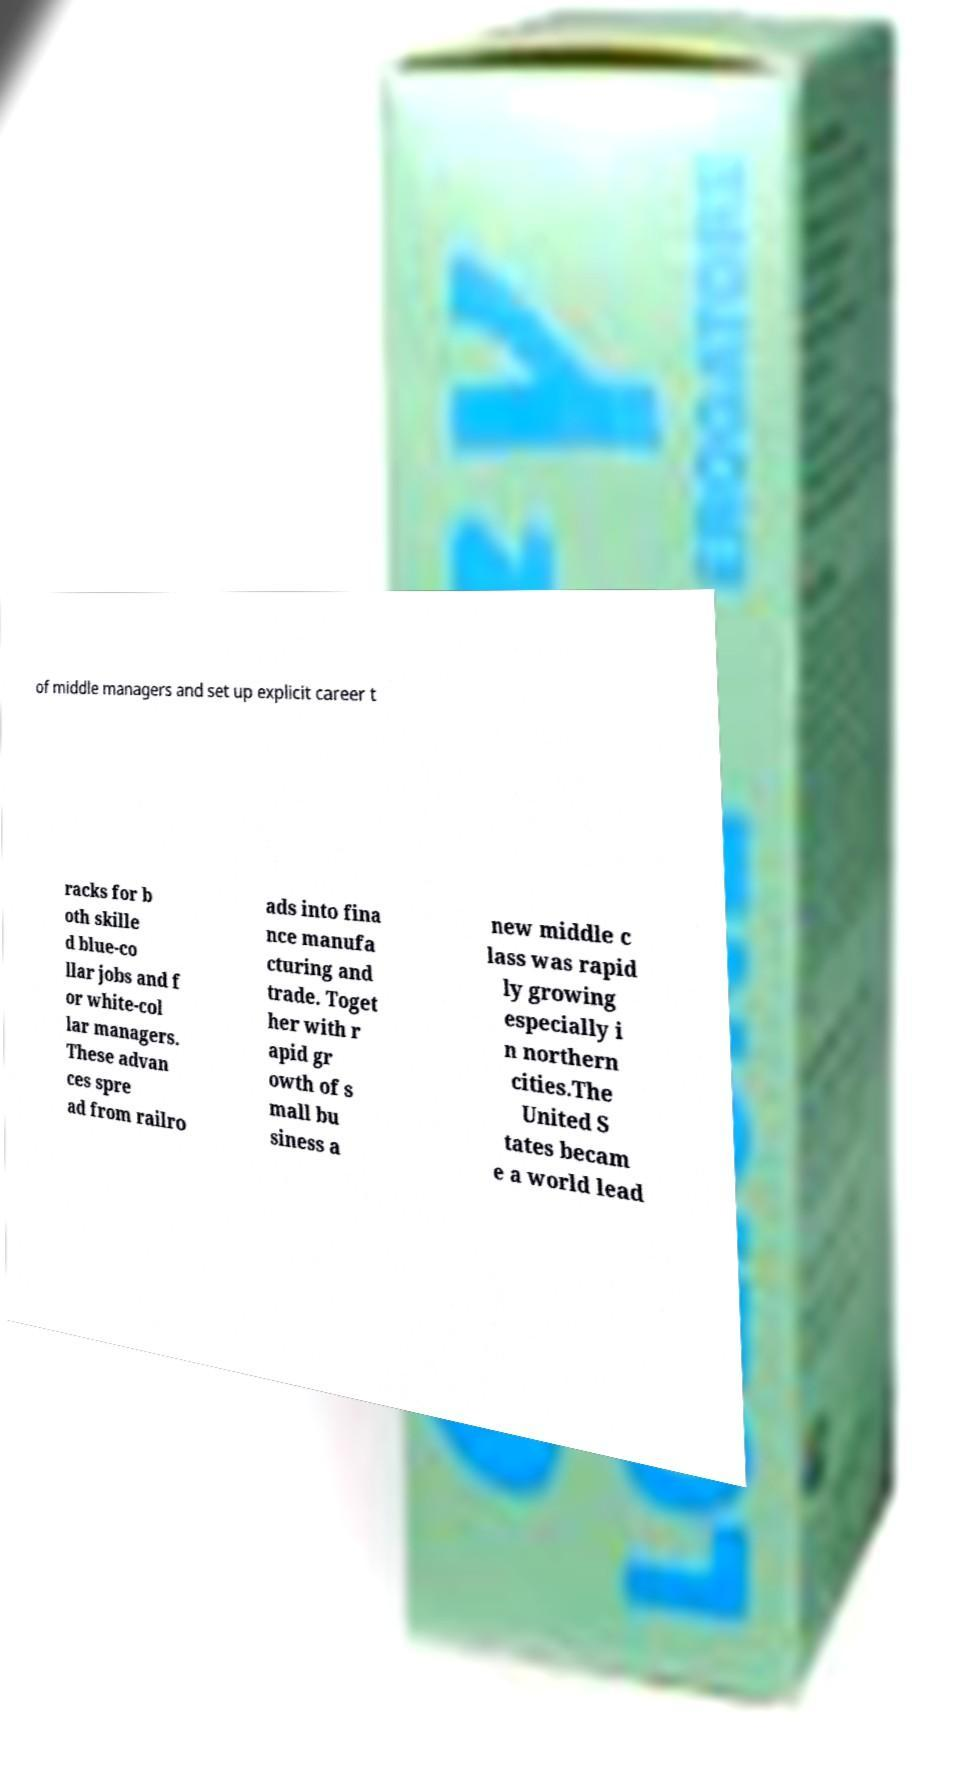Could you extract and type out the text from this image? of middle managers and set up explicit career t racks for b oth skille d blue-co llar jobs and f or white-col lar managers. These advan ces spre ad from railro ads into fina nce manufa cturing and trade. Toget her with r apid gr owth of s mall bu siness a new middle c lass was rapid ly growing especially i n northern cities.The United S tates becam e a world lead 